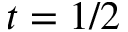<formula> <loc_0><loc_0><loc_500><loc_500>t = 1 / 2</formula> 